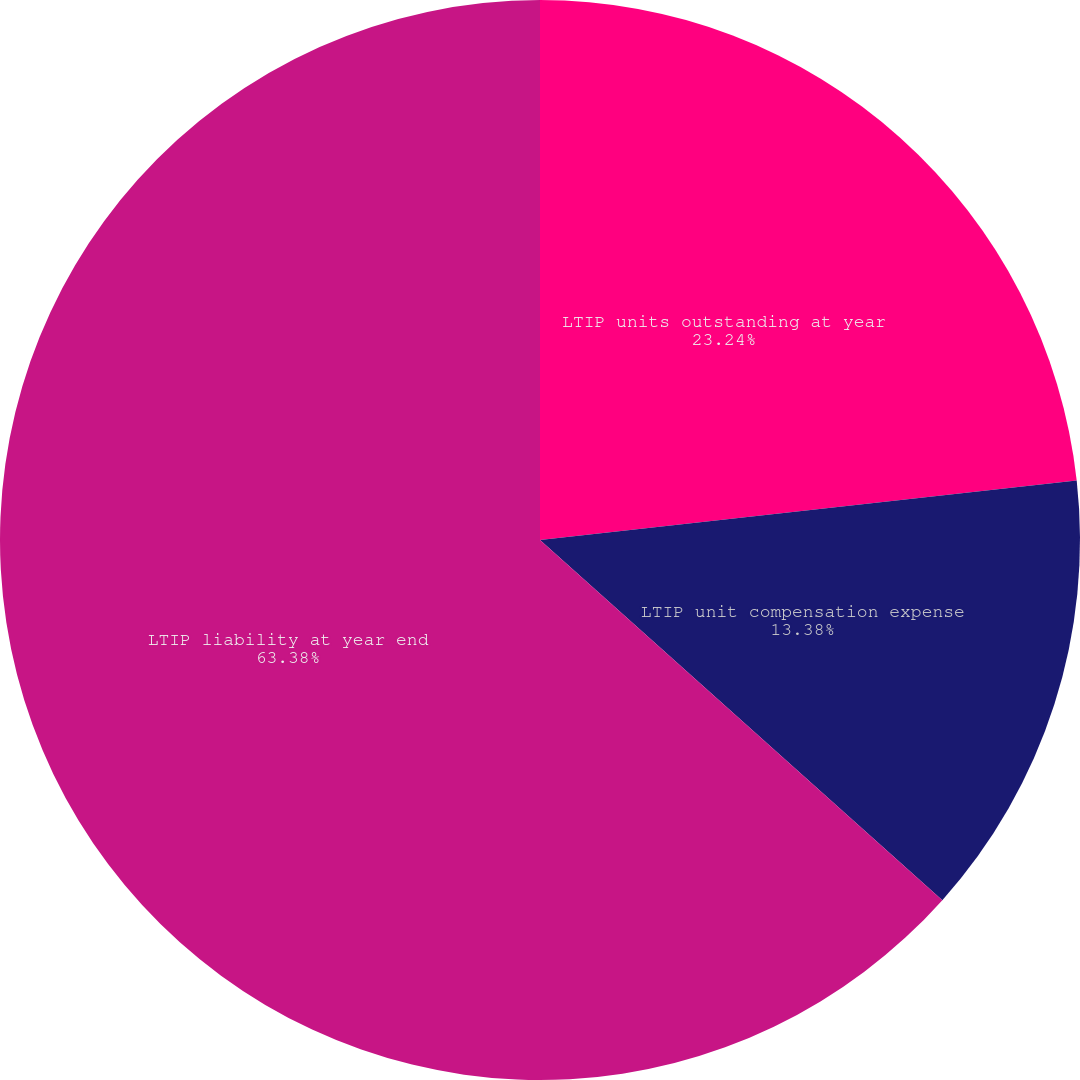Convert chart. <chart><loc_0><loc_0><loc_500><loc_500><pie_chart><fcel>LTIP units outstanding at year<fcel>LTIP unit compensation expense<fcel>LTIP liability at year end<nl><fcel>23.24%<fcel>13.38%<fcel>63.38%<nl></chart> 